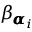Convert formula to latex. <formula><loc_0><loc_0><loc_500><loc_500>\beta _ { { \pm b { \alpha } } _ { i } }</formula> 